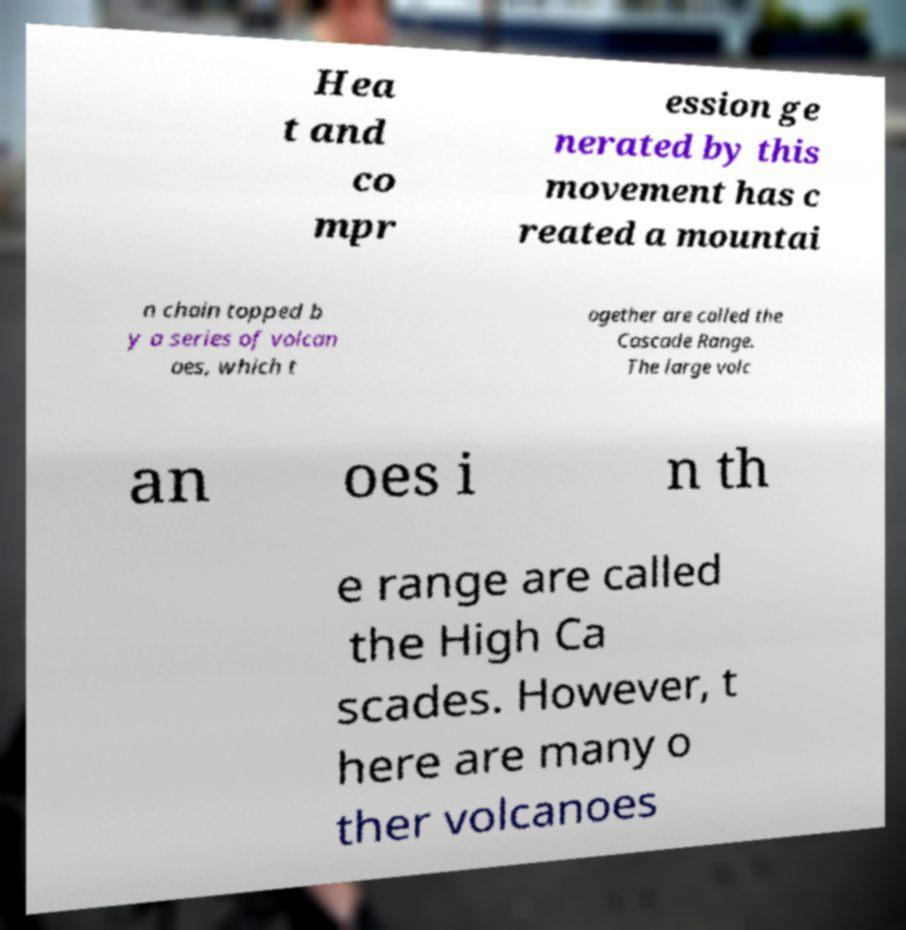What messages or text are displayed in this image? I need them in a readable, typed format. Hea t and co mpr ession ge nerated by this movement has c reated a mountai n chain topped b y a series of volcan oes, which t ogether are called the Cascade Range. The large volc an oes i n th e range are called the High Ca scades. However, t here are many o ther volcanoes 